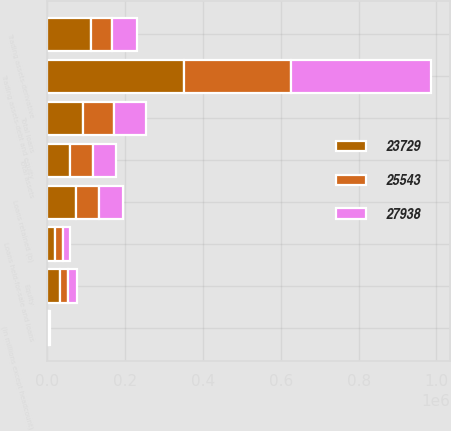Convert chart. <chart><loc_0><loc_0><loc_500><loc_500><stacked_bar_chart><ecel><fcel>(in millions except headcount)<fcel>Equity<fcel>Total assets<fcel>Trading assets-debt and equity<fcel>Trading assets-derivative<fcel>Loans retained (b)<fcel>Loans held-for-sale and loans<fcel>Total loans<nl><fcel>23729<fcel>2008<fcel>33000<fcel>58846<fcel>350812<fcel>112337<fcel>73108<fcel>18502<fcel>91610<nl><fcel>27938<fcel>2007<fcel>21000<fcel>58846<fcel>359775<fcel>63198<fcel>62247<fcel>17723<fcel>79970<nl><fcel>25543<fcel>2006<fcel>21000<fcel>58846<fcel>275077<fcel>54541<fcel>58846<fcel>21745<fcel>80591<nl></chart> 